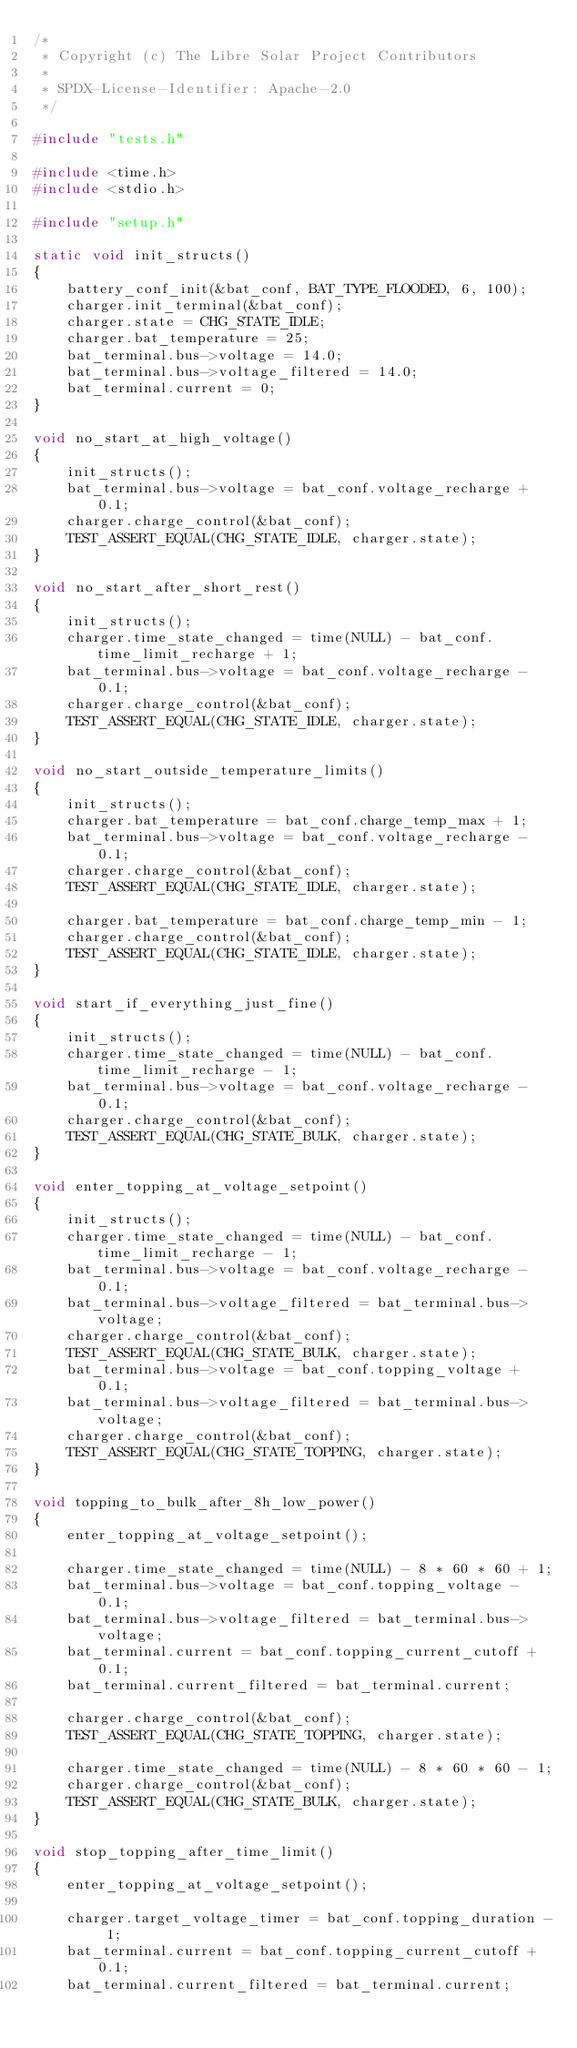Convert code to text. <code><loc_0><loc_0><loc_500><loc_500><_C++_>/*
 * Copyright (c) The Libre Solar Project Contributors
 *
 * SPDX-License-Identifier: Apache-2.0
 */

#include "tests.h"

#include <time.h>
#include <stdio.h>

#include "setup.h"

static void init_structs()
{
    battery_conf_init(&bat_conf, BAT_TYPE_FLOODED, 6, 100);
    charger.init_terminal(&bat_conf);
    charger.state = CHG_STATE_IDLE;
    charger.bat_temperature = 25;
    bat_terminal.bus->voltage = 14.0;
    bat_terminal.bus->voltage_filtered = 14.0;
    bat_terminal.current = 0;
}

void no_start_at_high_voltage()
{
    init_structs();
    bat_terminal.bus->voltage = bat_conf.voltage_recharge + 0.1;
    charger.charge_control(&bat_conf);
    TEST_ASSERT_EQUAL(CHG_STATE_IDLE, charger.state);
}

void no_start_after_short_rest()
{
    init_structs();
    charger.time_state_changed = time(NULL) - bat_conf.time_limit_recharge + 1;
    bat_terminal.bus->voltage = bat_conf.voltage_recharge - 0.1;
    charger.charge_control(&bat_conf);
    TEST_ASSERT_EQUAL(CHG_STATE_IDLE, charger.state);
}

void no_start_outside_temperature_limits()
{
    init_structs();
    charger.bat_temperature = bat_conf.charge_temp_max + 1;
    bat_terminal.bus->voltage = bat_conf.voltage_recharge - 0.1;
    charger.charge_control(&bat_conf);
    TEST_ASSERT_EQUAL(CHG_STATE_IDLE, charger.state);

    charger.bat_temperature = bat_conf.charge_temp_min - 1;
    charger.charge_control(&bat_conf);
    TEST_ASSERT_EQUAL(CHG_STATE_IDLE, charger.state);
}

void start_if_everything_just_fine()
{
    init_structs();
    charger.time_state_changed = time(NULL) - bat_conf.time_limit_recharge - 1;
    bat_terminal.bus->voltage = bat_conf.voltage_recharge - 0.1;
    charger.charge_control(&bat_conf);
    TEST_ASSERT_EQUAL(CHG_STATE_BULK, charger.state);
}

void enter_topping_at_voltage_setpoint()
{
    init_structs();
    charger.time_state_changed = time(NULL) - bat_conf.time_limit_recharge - 1;
    bat_terminal.bus->voltage = bat_conf.voltage_recharge - 0.1;
    bat_terminal.bus->voltage_filtered = bat_terminal.bus->voltage;
    charger.charge_control(&bat_conf);
    TEST_ASSERT_EQUAL(CHG_STATE_BULK, charger.state);
    bat_terminal.bus->voltage = bat_conf.topping_voltage + 0.1;
    bat_terminal.bus->voltage_filtered = bat_terminal.bus->voltage;
    charger.charge_control(&bat_conf);
    TEST_ASSERT_EQUAL(CHG_STATE_TOPPING, charger.state);
}

void topping_to_bulk_after_8h_low_power()
{
    enter_topping_at_voltage_setpoint();

    charger.time_state_changed = time(NULL) - 8 * 60 * 60 + 1;
    bat_terminal.bus->voltage = bat_conf.topping_voltage - 0.1;
    bat_terminal.bus->voltage_filtered = bat_terminal.bus->voltage;
    bat_terminal.current = bat_conf.topping_current_cutoff + 0.1;
    bat_terminal.current_filtered = bat_terminal.current;

    charger.charge_control(&bat_conf);
    TEST_ASSERT_EQUAL(CHG_STATE_TOPPING, charger.state);

    charger.time_state_changed = time(NULL) - 8 * 60 * 60 - 1;
    charger.charge_control(&bat_conf);
    TEST_ASSERT_EQUAL(CHG_STATE_BULK, charger.state);
}

void stop_topping_after_time_limit()
{
    enter_topping_at_voltage_setpoint();

    charger.target_voltage_timer = bat_conf.topping_duration - 1;
    bat_terminal.current = bat_conf.topping_current_cutoff + 0.1;
    bat_terminal.current_filtered = bat_terminal.current;</code> 